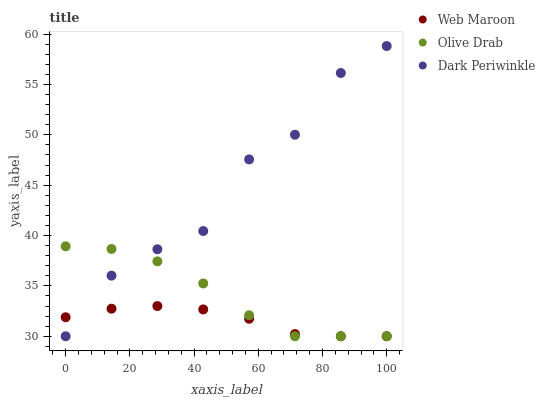Does Web Maroon have the minimum area under the curve?
Answer yes or no. Yes. Does Dark Periwinkle have the maximum area under the curve?
Answer yes or no. Yes. Does Olive Drab have the minimum area under the curve?
Answer yes or no. No. Does Olive Drab have the maximum area under the curve?
Answer yes or no. No. Is Web Maroon the smoothest?
Answer yes or no. Yes. Is Dark Periwinkle the roughest?
Answer yes or no. Yes. Is Olive Drab the smoothest?
Answer yes or no. No. Is Olive Drab the roughest?
Answer yes or no. No. Does Web Maroon have the lowest value?
Answer yes or no. Yes. Does Dark Periwinkle have the highest value?
Answer yes or no. Yes. Does Olive Drab have the highest value?
Answer yes or no. No. Does Web Maroon intersect Olive Drab?
Answer yes or no. Yes. Is Web Maroon less than Olive Drab?
Answer yes or no. No. Is Web Maroon greater than Olive Drab?
Answer yes or no. No. 